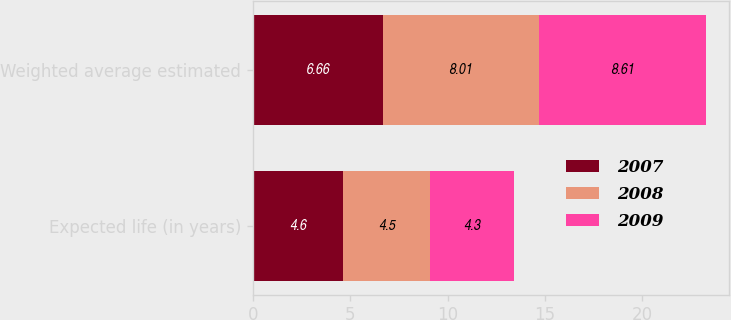Convert chart. <chart><loc_0><loc_0><loc_500><loc_500><stacked_bar_chart><ecel><fcel>Expected life (in years)<fcel>Weighted average estimated<nl><fcel>2007<fcel>4.6<fcel>6.66<nl><fcel>2008<fcel>4.5<fcel>8.01<nl><fcel>2009<fcel>4.3<fcel>8.61<nl></chart> 